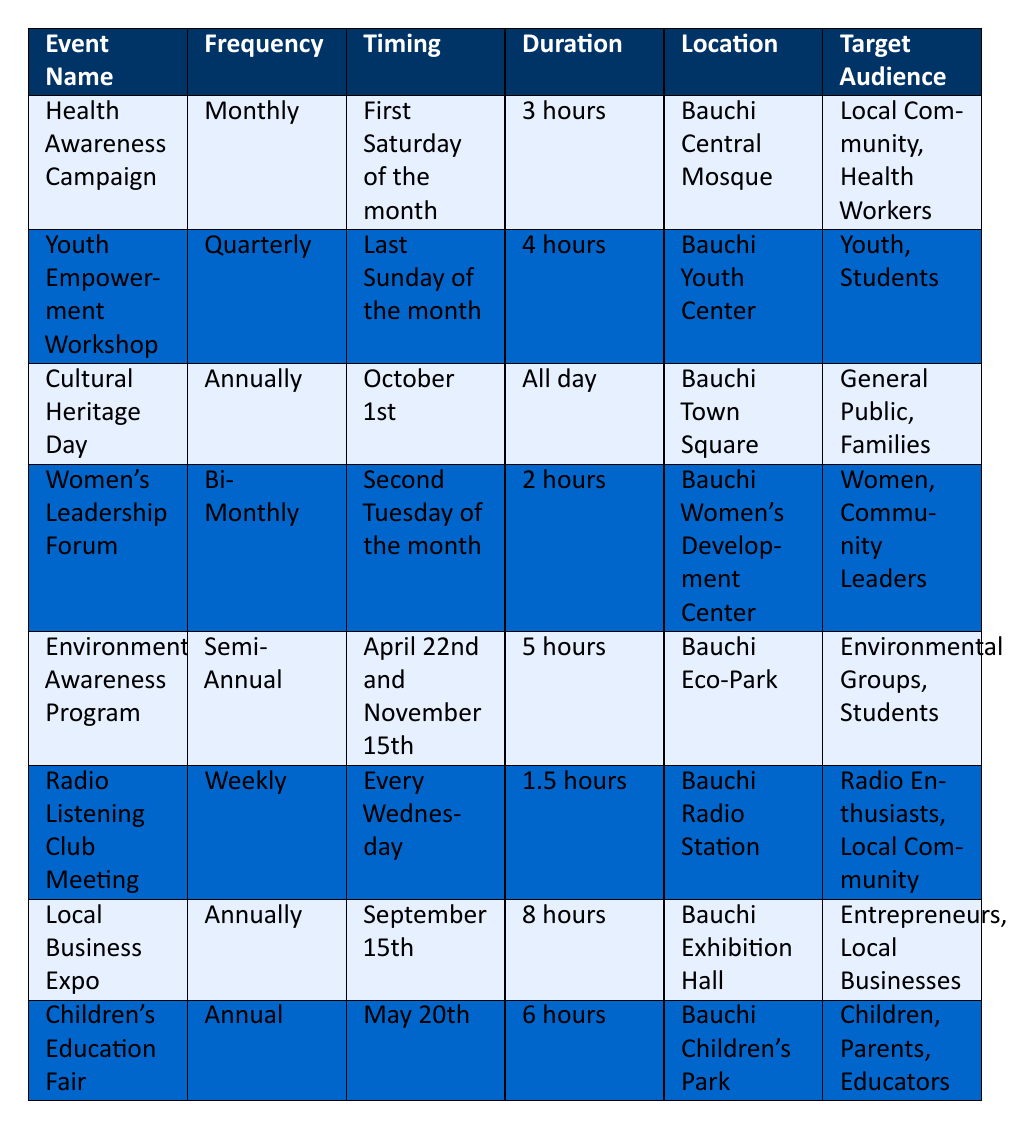What is the duration of the Health Awareness Campaign? The duration can be found in the row for the Health Awareness Campaign under the Duration column, which states "3 hours."
Answer: 3 hours How often does the Radio Listening Club Meeting occur? The frequency of the Radio Listening Club Meeting is listed in the Frequency column, which indicates it occurs "Weekly."
Answer: Weekly On which date is the Environmental Awareness Program scheduled? The timing for the Environmental Awareness Program is listed, and it mentions two specific dates: "April 22nd and November 15th."
Answer: April 22nd and November 15th Is the Women’s Leadership Forum held more frequently than the Cultural Heritage Day? The Women’s Leadership Forum is held Bi-Monthly (every two months) while the Cultural Heritage Day is held Annually (once a year). Bi-Monthly is more frequent than Annually.
Answer: Yes What is the average duration of all community engagement events? To find the average duration, first add up all the durations: 3 + 4 + 24 (All day counted as 24 hours) + 2 + 5 + 1.5 + 8 + 6 = 49.5 hours. Then, divide by the number of events (8) to get the average: 49.5 / 8 = 6.1875 hours.
Answer: 6.19 hours Where is the Youth Empowerment Workshop held? The location can be found in the row for the Youth Empowerment Workshop under the Location column, which specifies "Bauchi Youth Center."
Answer: Bauchi Youth Center Does the Local Business Expo occur before the Children’s Education Fair in the calendar year? The Local Business Expo happens on September 15th, while the Children’s Education Fair is on May 20th. Since September comes after May, the Local Business Expo occurs later in the year.
Answer: No What is the total number of events that target Children or Parents? The events targeting Children or Parents can be found by checking the target audience columns: the Children’s Education Fair is the only event that mentions them. Therefore, the total is 1 event.
Answer: 1 event 